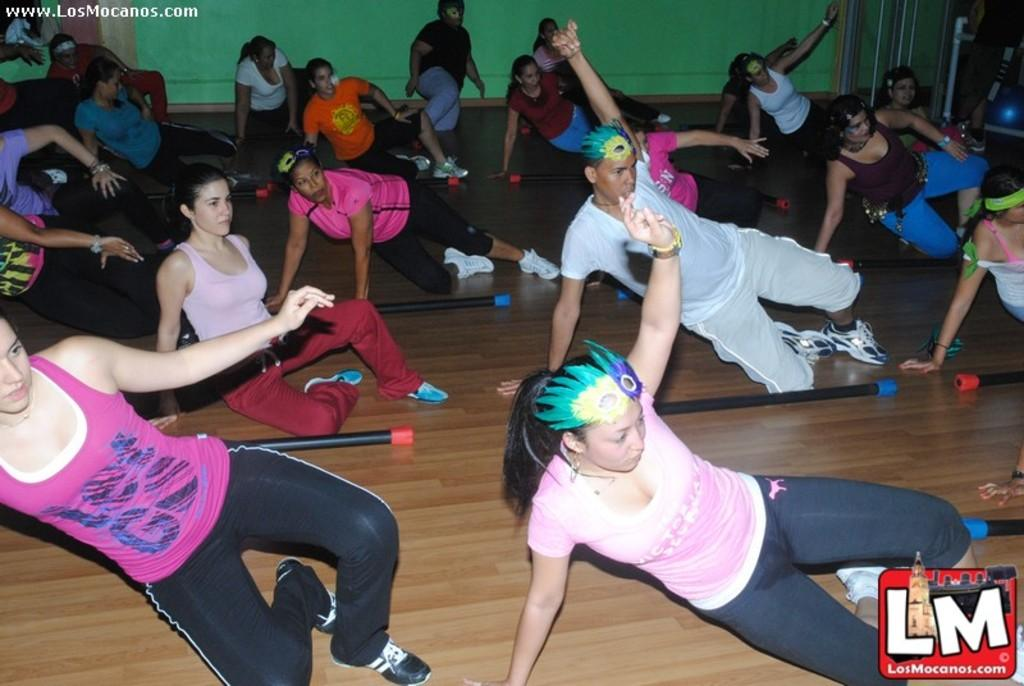What are the people in the image doing? The people in the image are doing exercises. What objects can be seen in the image besides the people? There are sticks visible in the image. What is in the background of the image? There is a wall in the background of the image. What surface can be seen at the bottom of the image? There is a floor visible at the bottom of the image. How many girls are participating in the discussion in the image? There is no discussion or girls present in the image; it features people doing exercises. What type of silk is draped over the exercise equipment in the image? There is no silk present in the image; it only shows people doing exercises with sticks. 